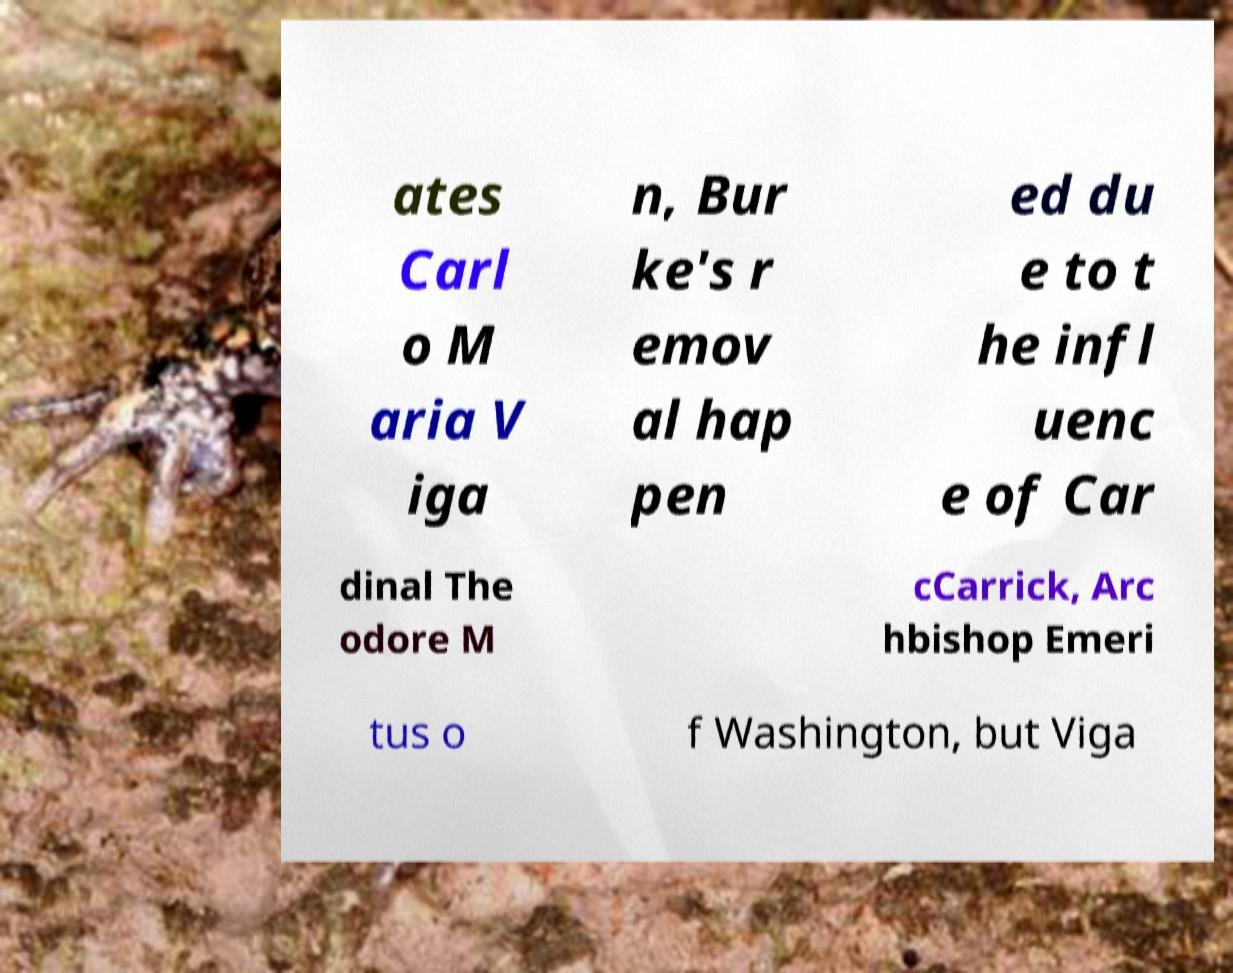Can you accurately transcribe the text from the provided image for me? ates Carl o M aria V iga n, Bur ke's r emov al hap pen ed du e to t he infl uenc e of Car dinal The odore M cCarrick, Arc hbishop Emeri tus o f Washington, but Viga 